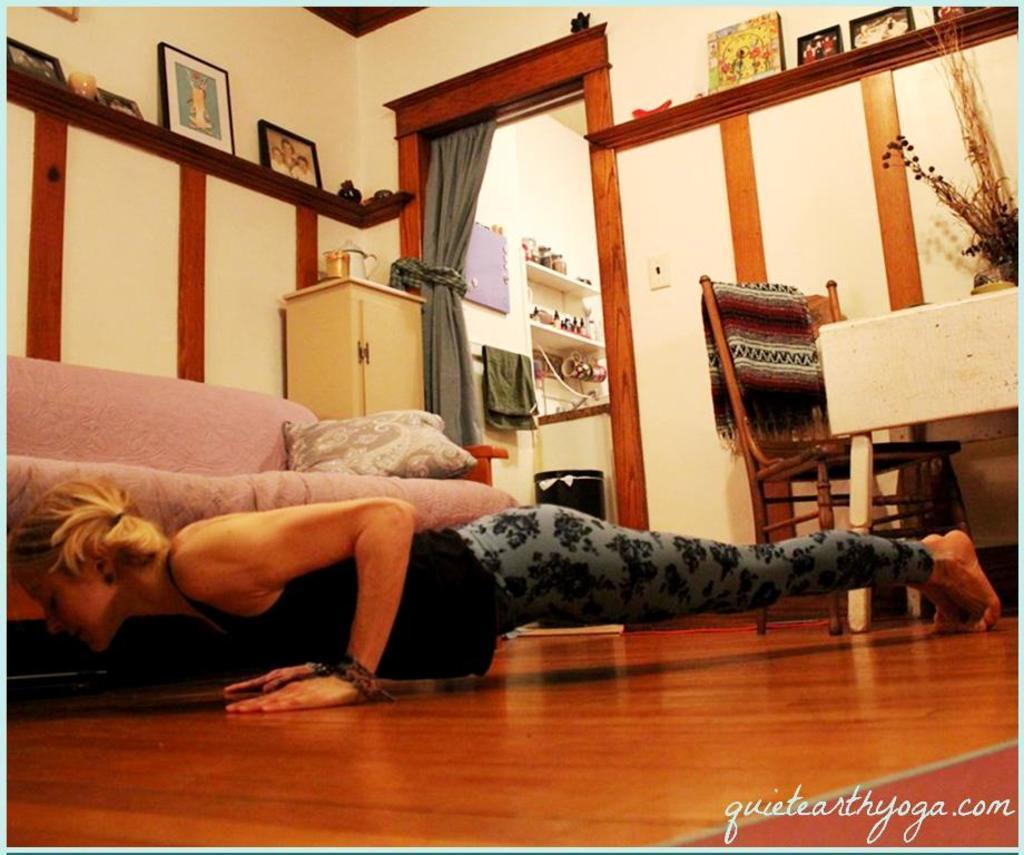Please provide a concise description of this image. There is a woman on a floor. She is doing exercise. This is sofa. This is a chair. 